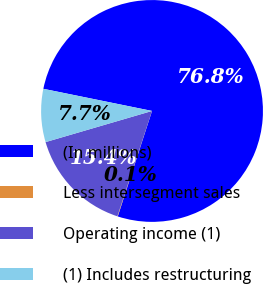Convert chart to OTSL. <chart><loc_0><loc_0><loc_500><loc_500><pie_chart><fcel>(In millions)<fcel>Less intersegment sales<fcel>Operating income (1)<fcel>(1) Includes restructuring<nl><fcel>76.8%<fcel>0.06%<fcel>15.41%<fcel>7.73%<nl></chart> 